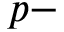Convert formula to latex. <formula><loc_0><loc_0><loc_500><loc_500>p -</formula> 